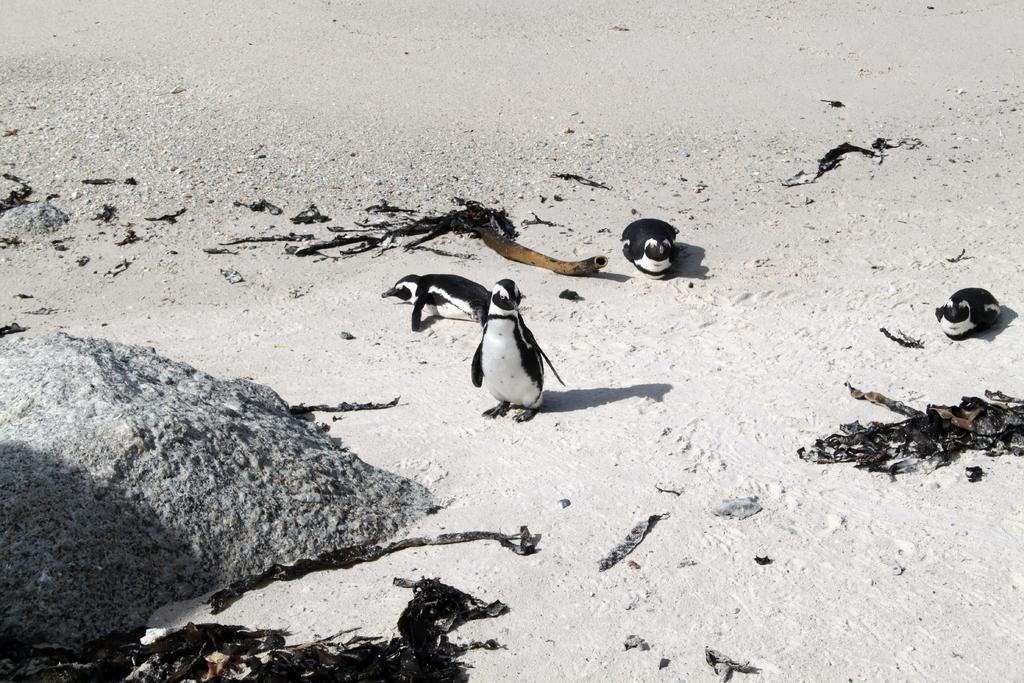What type of animals are in the image? There are penguins in the image. Where are the penguins located? The penguins are on the sand. What other object can be seen in the image? There is a rock in the image. What type of gold object is visible in the image? There is no gold object present in the image; it features penguins on the sand and a rock. What type of bread can be seen in the image? There is no bread present in the image. 